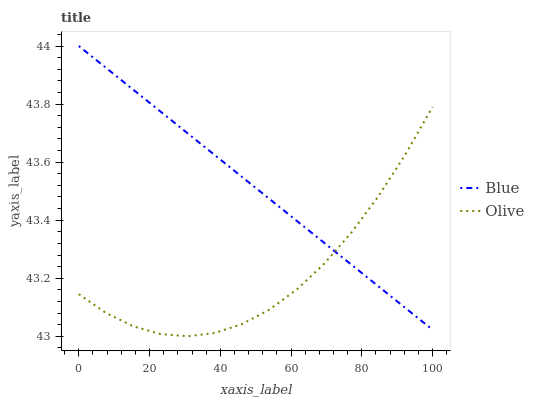Does Olive have the minimum area under the curve?
Answer yes or no. Yes. Does Blue have the maximum area under the curve?
Answer yes or no. Yes. Does Olive have the maximum area under the curve?
Answer yes or no. No. Is Blue the smoothest?
Answer yes or no. Yes. Is Olive the roughest?
Answer yes or no. Yes. Is Olive the smoothest?
Answer yes or no. No. Does Olive have the lowest value?
Answer yes or no. Yes. Does Blue have the highest value?
Answer yes or no. Yes. Does Olive have the highest value?
Answer yes or no. No. Does Olive intersect Blue?
Answer yes or no. Yes. Is Olive less than Blue?
Answer yes or no. No. Is Olive greater than Blue?
Answer yes or no. No. 